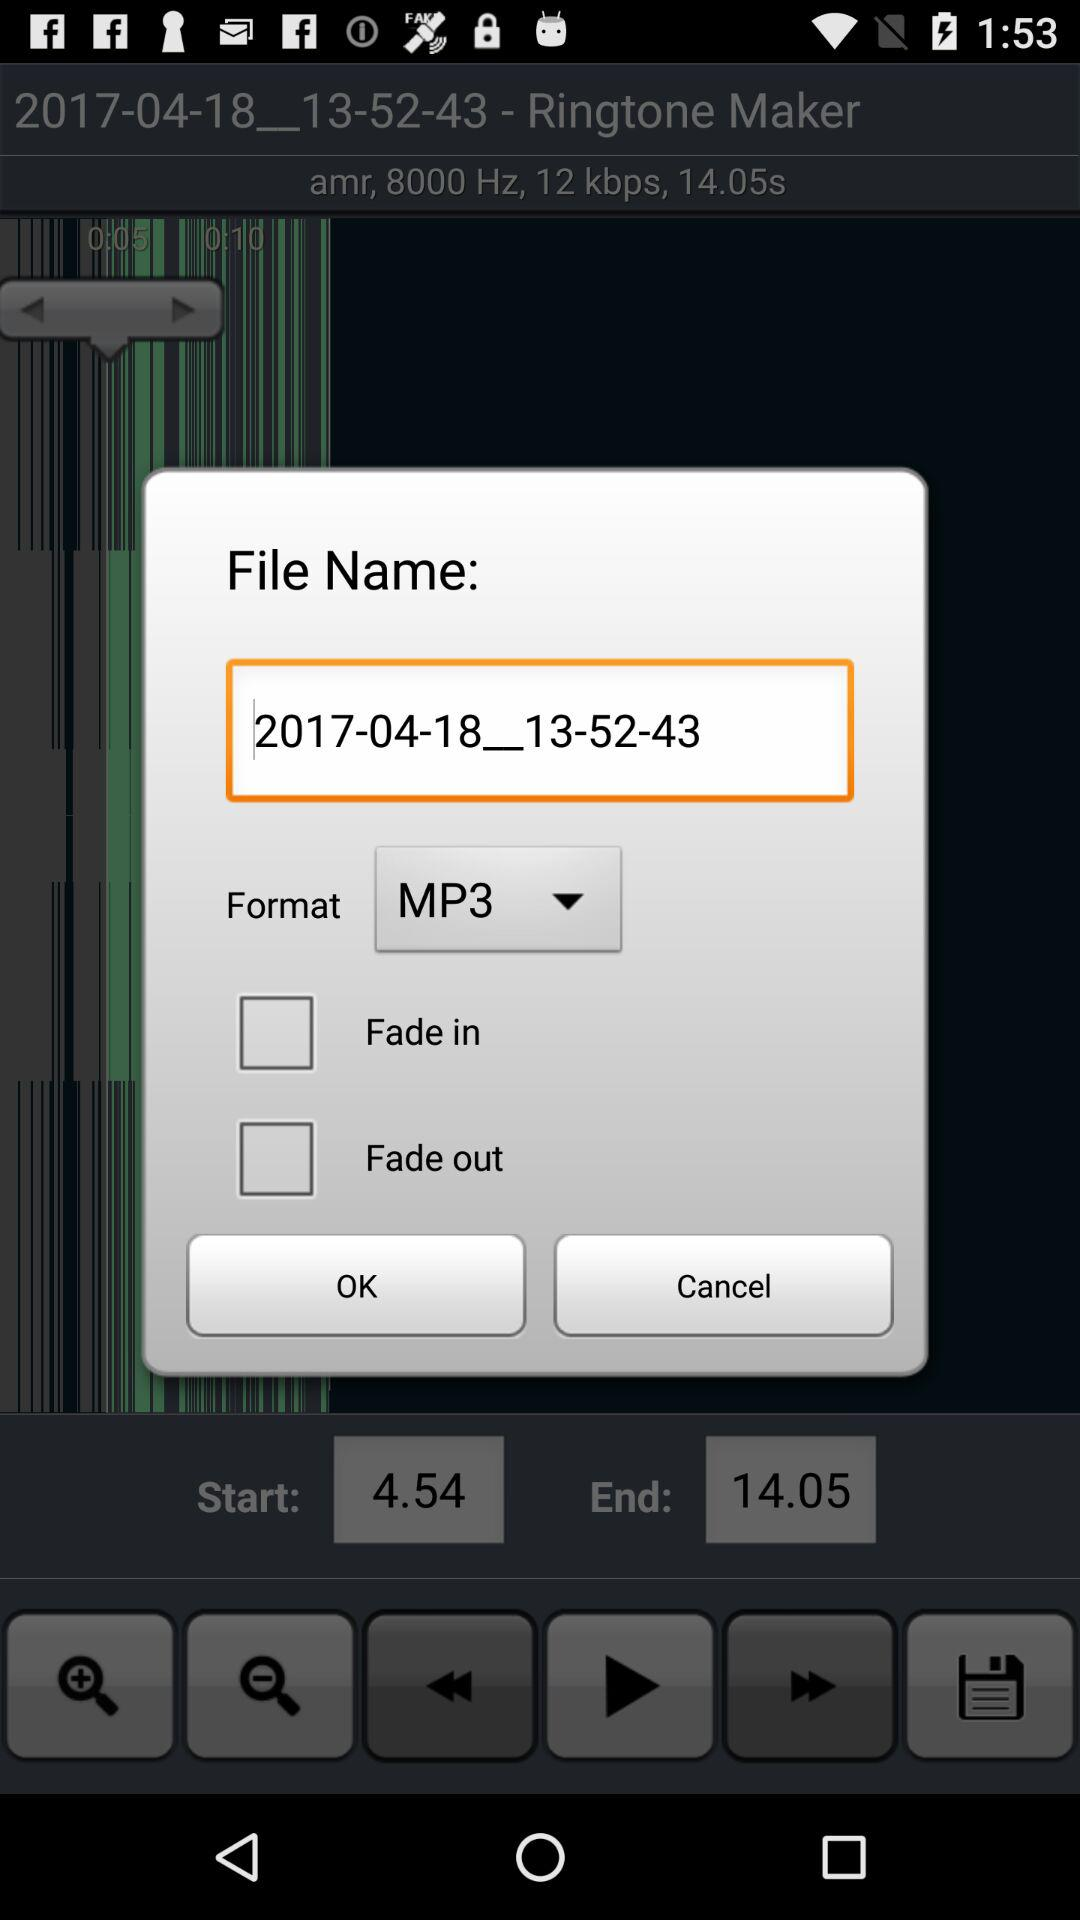What is the name of the file? The file name is 2017-04-18__13-52-43. 